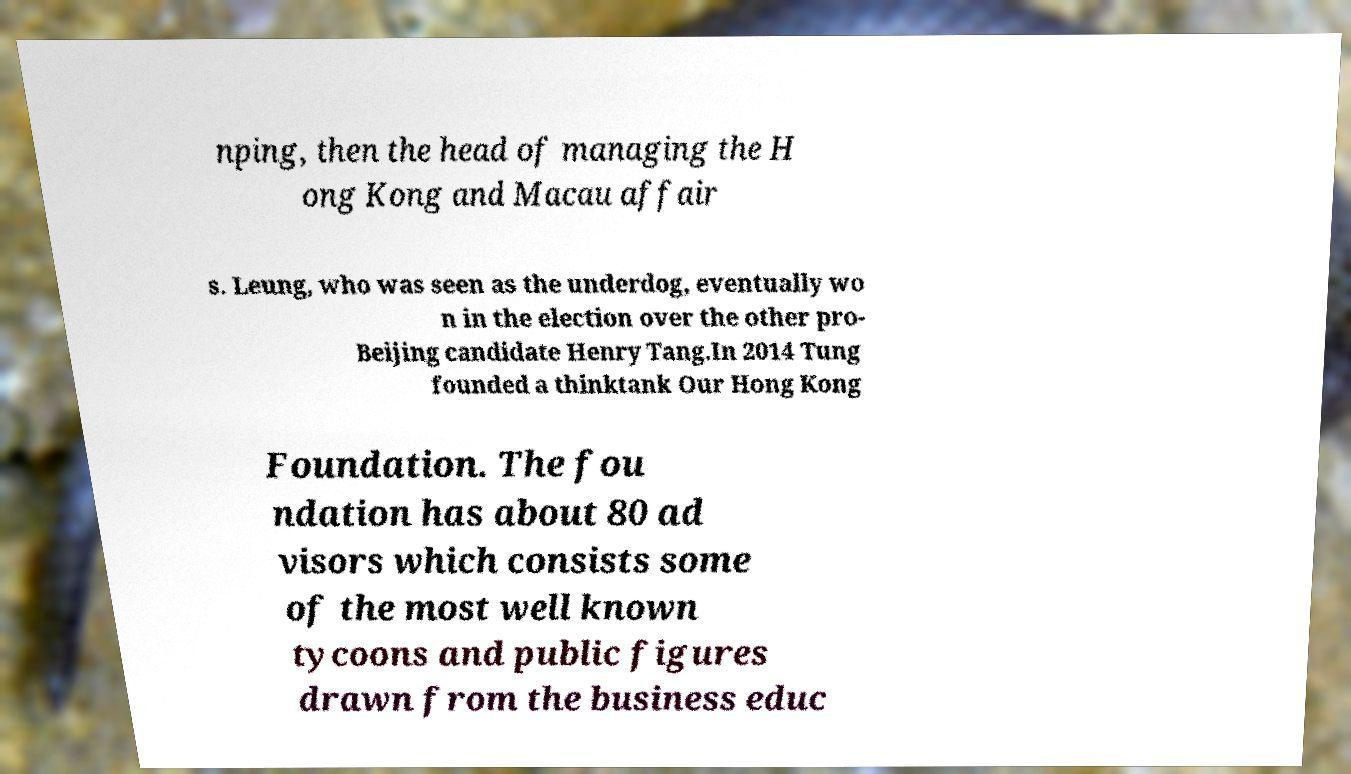There's text embedded in this image that I need extracted. Can you transcribe it verbatim? nping, then the head of managing the H ong Kong and Macau affair s. Leung, who was seen as the underdog, eventually wo n in the election over the other pro- Beijing candidate Henry Tang.In 2014 Tung founded a thinktank Our Hong Kong Foundation. The fou ndation has about 80 ad visors which consists some of the most well known tycoons and public figures drawn from the business educ 